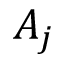Convert formula to latex. <formula><loc_0><loc_0><loc_500><loc_500>A _ { j }</formula> 